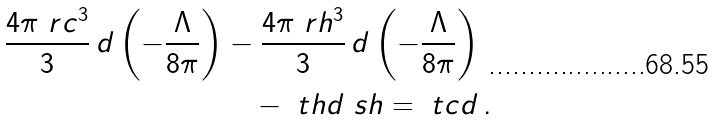Convert formula to latex. <formula><loc_0><loc_0><loc_500><loc_500>\frac { 4 \pi \ r c ^ { 3 } } { 3 } \, d \left ( - \frac { \Lambda } { 8 \pi } \right ) & - \frac { 4 \pi \ r h ^ { 3 } } { 3 } \, d \left ( - \frac { \Lambda } { 8 \pi } \right ) \\ & \quad - \ t h d \ s h = \ t c d \, .</formula> 